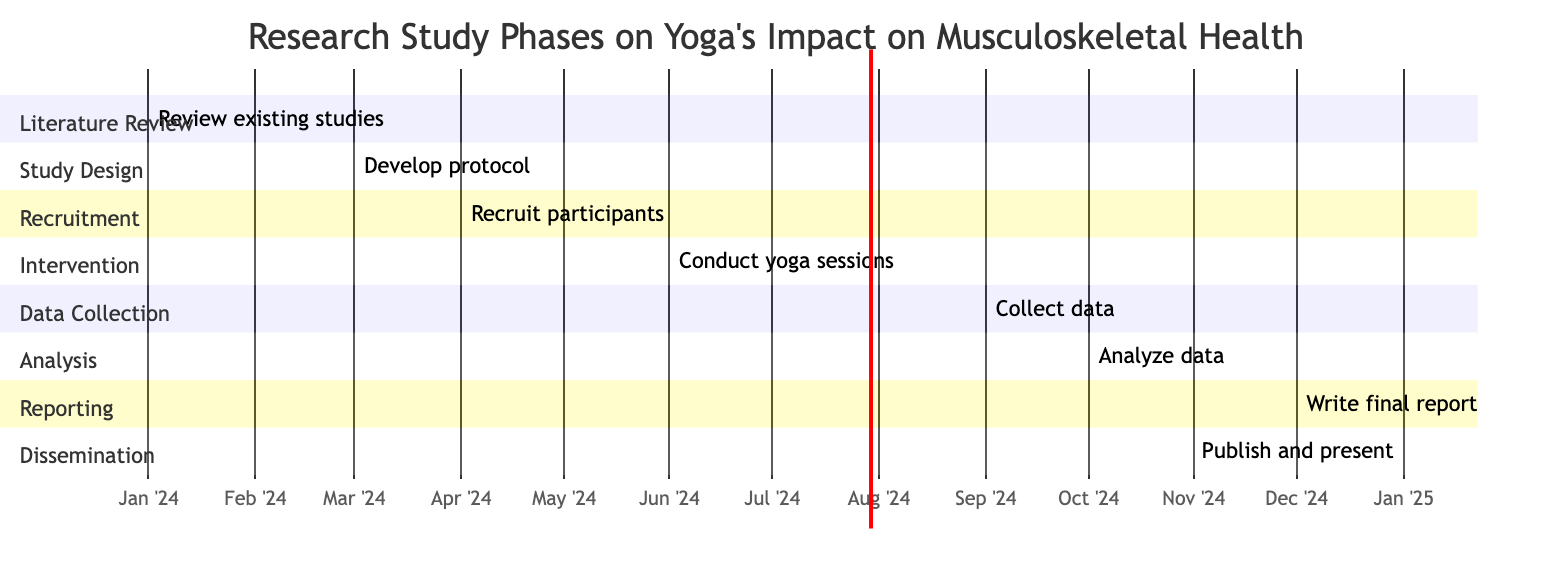What is the total duration of the study phases? By adding the durations of all the phases listed in the diagram: Literature Review (2 months) + Study Design (1 month) + Recruitment (2 months) + Intervention (3 months) + Data Collection (1 month) + Data Analysis (2 months) + Report Writing (1 month) + Dissemination (2 months) = 12 months.
Answer: 12 months In which month does the implementation of the yoga intervention begin? The yoga intervention starts on June 1, 2024, as indicated in the "Implementation of Yoga Intervention" section.
Answer: June 1, 2024 How many total phases are presented in the Gantt chart? The chart lists 8 distinct phases, each outlined in a separate section of the diagram.
Answer: 8 What is the duration of the data analysis phase? The duration of the "Data Analysis" phase is explicitly shown as 2 months in the diagram.
Answer: 2 months What section follows the data collection section in the timeline? The section that follows "Data Collection" is "Data Analysis" as seen in the sequential arrangement of the phases.
Answer: Data Analysis Which phase has the longest duration? The "Implementation of Yoga Intervention" phase is the longest, lasting 3 months, according to the diagram.
Answer: Implementation of Yoga Intervention When is the report writing phase scheduled to take place? The "Report Writing" phase is scheduled to occur in December 2024, starting from December 1 and lasting for 1 month.
Answer: December 2024 Which phase comes directly before the dissemination of findings? The phase that comes directly before "Dissemination of Findings" is "Report Writing," as they are sequentially arranged in the diagram.
Answer: Report Writing How many months is allocated for the recruitment of participants? The "Recruitment of Participants" phase is allocated a duration of 2 months, as stated in the diagram.
Answer: 2 months 